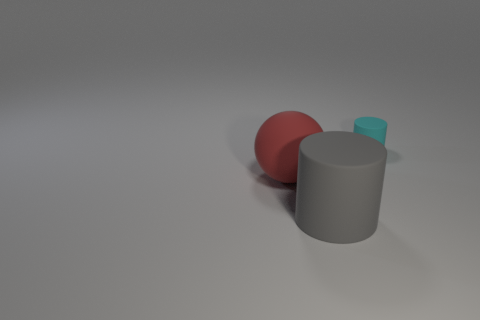Add 2 large matte objects. How many objects exist? 5 Subtract all spheres. How many objects are left? 2 Subtract 0 green cylinders. How many objects are left? 3 Subtract all large spheres. Subtract all tiny cylinders. How many objects are left? 1 Add 2 big spheres. How many big spheres are left? 3 Add 2 gray rubber cylinders. How many gray rubber cylinders exist? 3 